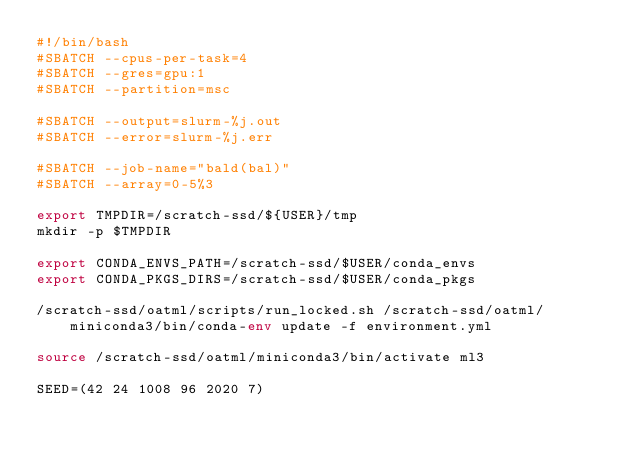Convert code to text. <code><loc_0><loc_0><loc_500><loc_500><_Bash_>#!/bin/bash
#SBATCH --cpus-per-task=4
#SBATCH --gres=gpu:1
#SBATCH --partition=msc

#SBATCH --output=slurm-%j.out
#SBATCH --error=slurm-%j.err

#SBATCH --job-name="bald(bal)"
#SBATCH --array=0-5%3

export TMPDIR=/scratch-ssd/${USER}/tmp
mkdir -p $TMPDIR

export CONDA_ENVS_PATH=/scratch-ssd/$USER/conda_envs
export CONDA_PKGS_DIRS=/scratch-ssd/$USER/conda_pkgs

/scratch-ssd/oatml/scripts/run_locked.sh /scratch-ssd/oatml/miniconda3/bin/conda-env update -f environment.yml

source /scratch-ssd/oatml/miniconda3/bin/activate ml3

SEED=(42 24 1008 96 2020 7)</code> 